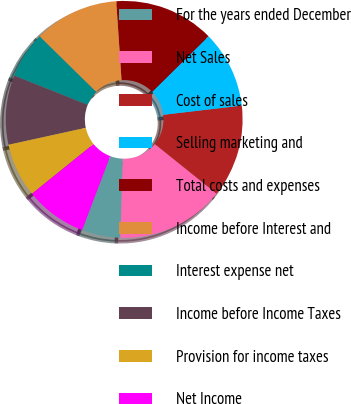<chart> <loc_0><loc_0><loc_500><loc_500><pie_chart><fcel>For the years ended December<fcel>Net Sales<fcel>Cost of sales<fcel>Selling marketing and<fcel>Total costs and expenses<fcel>Income before Interest and<fcel>Interest expense net<fcel>Income before Income Taxes<fcel>Provision for income taxes<fcel>Net Income<nl><fcel>5.26%<fcel>14.74%<fcel>12.63%<fcel>10.53%<fcel>13.68%<fcel>11.58%<fcel>6.32%<fcel>9.47%<fcel>7.37%<fcel>8.42%<nl></chart> 